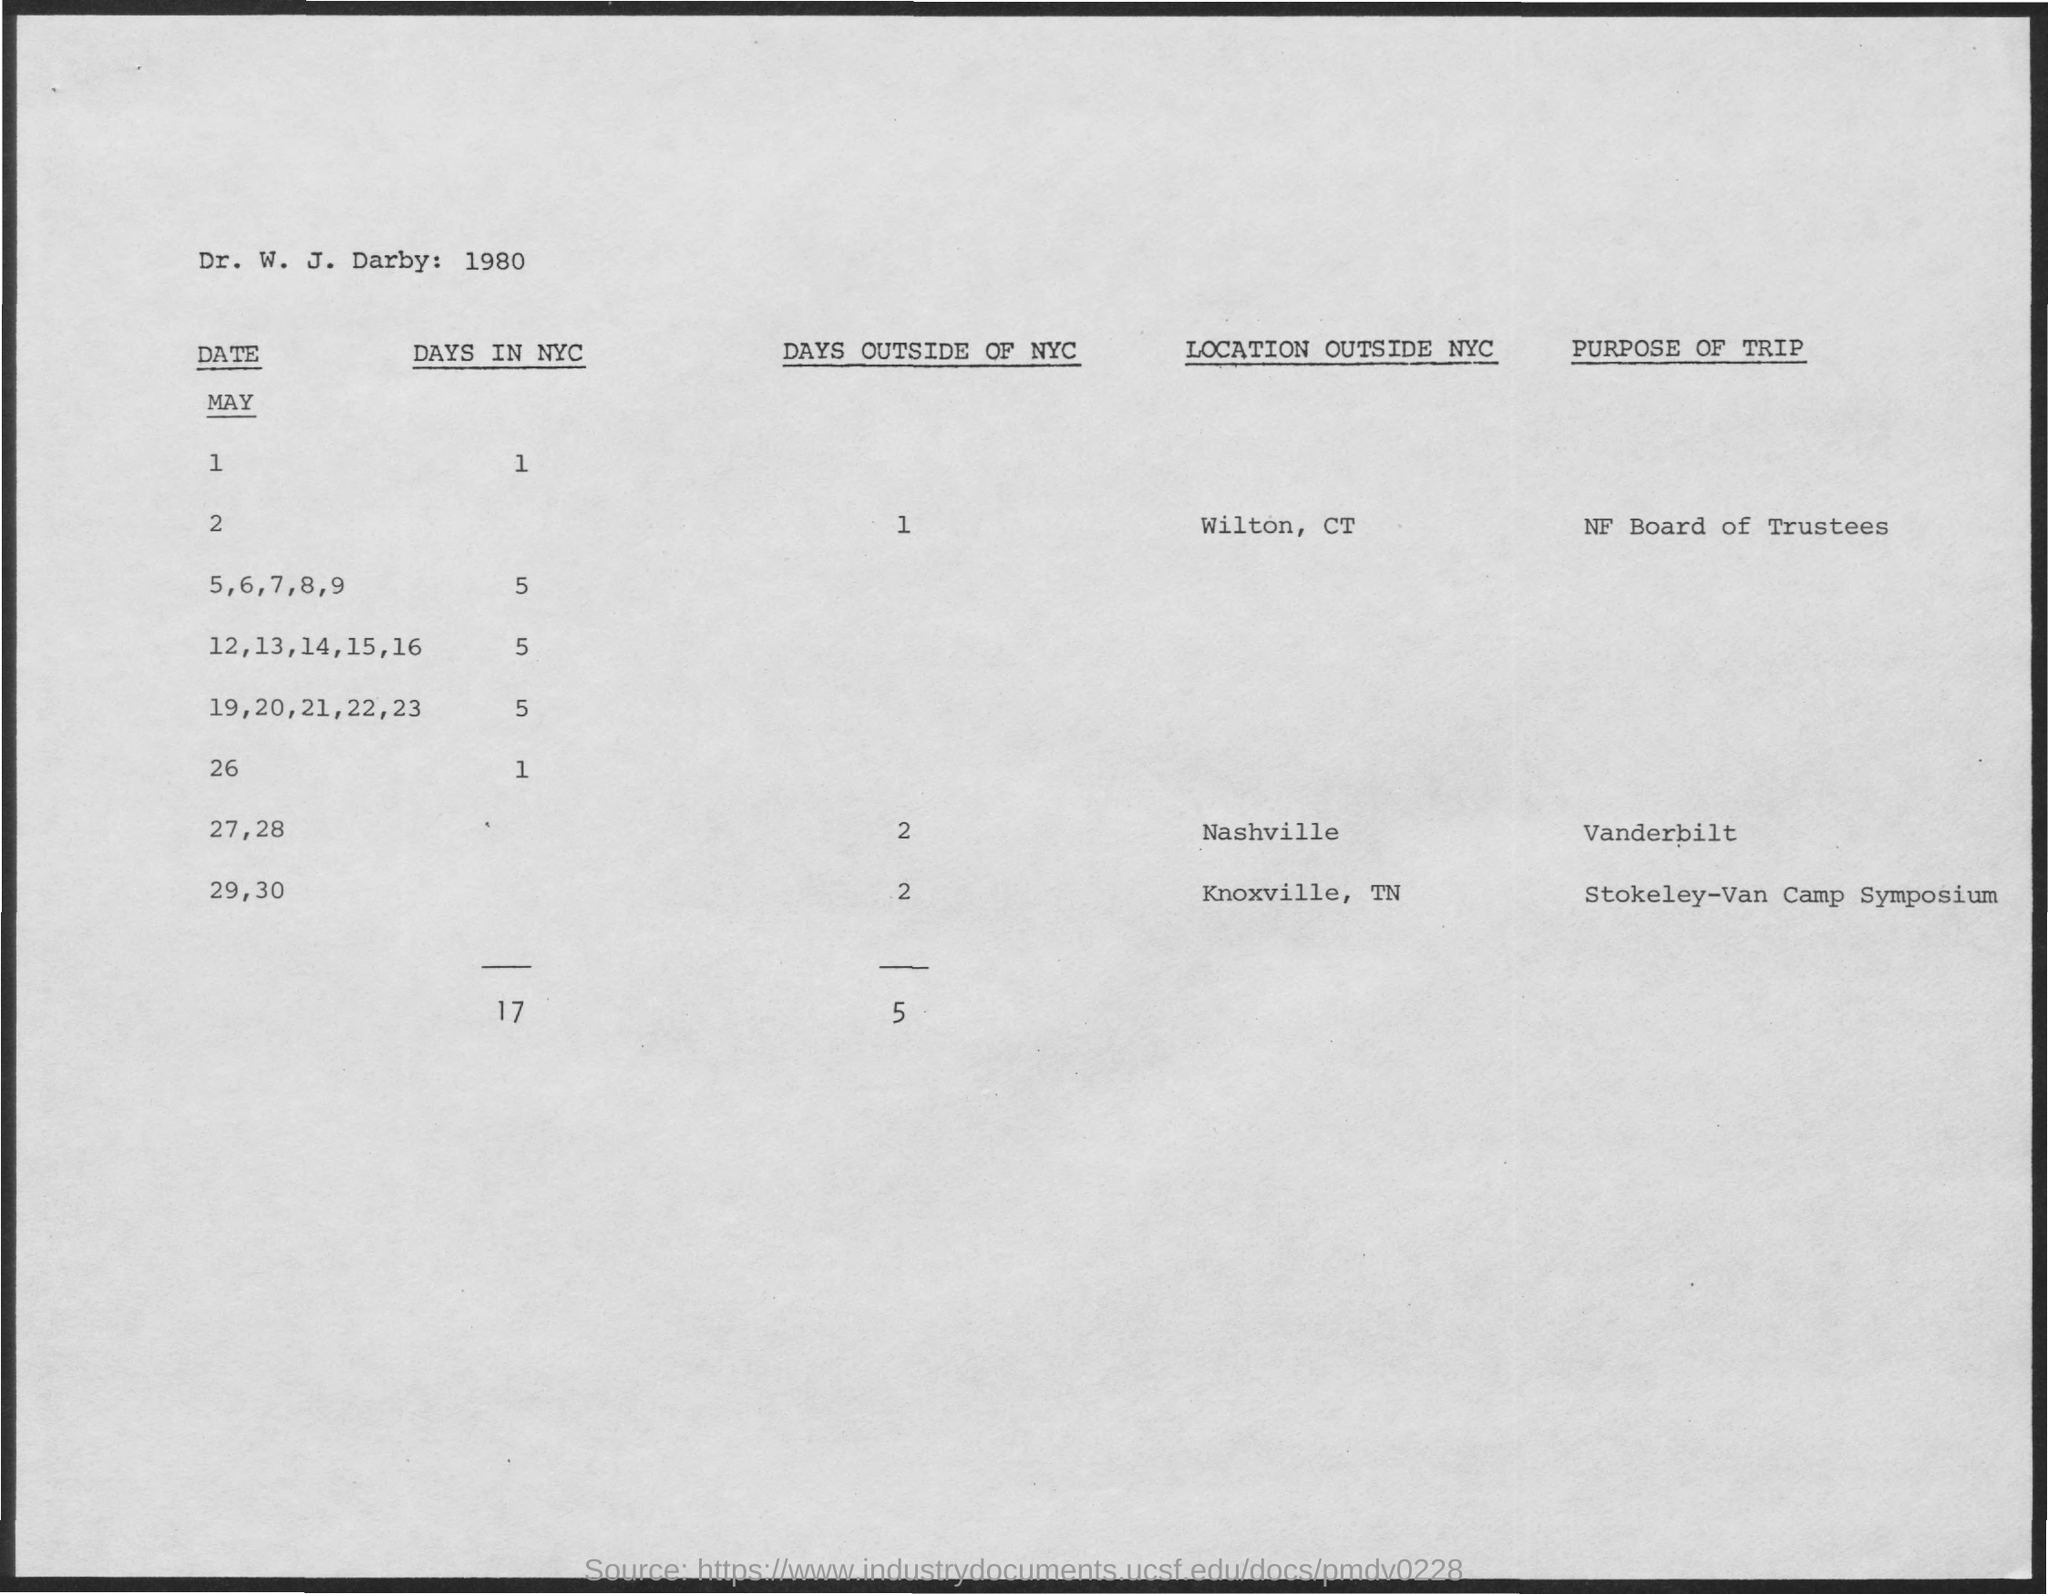Identify some key points in this picture. On May 2, the purpose of the trip by the NF Board of Trustees will be to... The number of days spent outside of New York City on May 27 and 28 is two. 